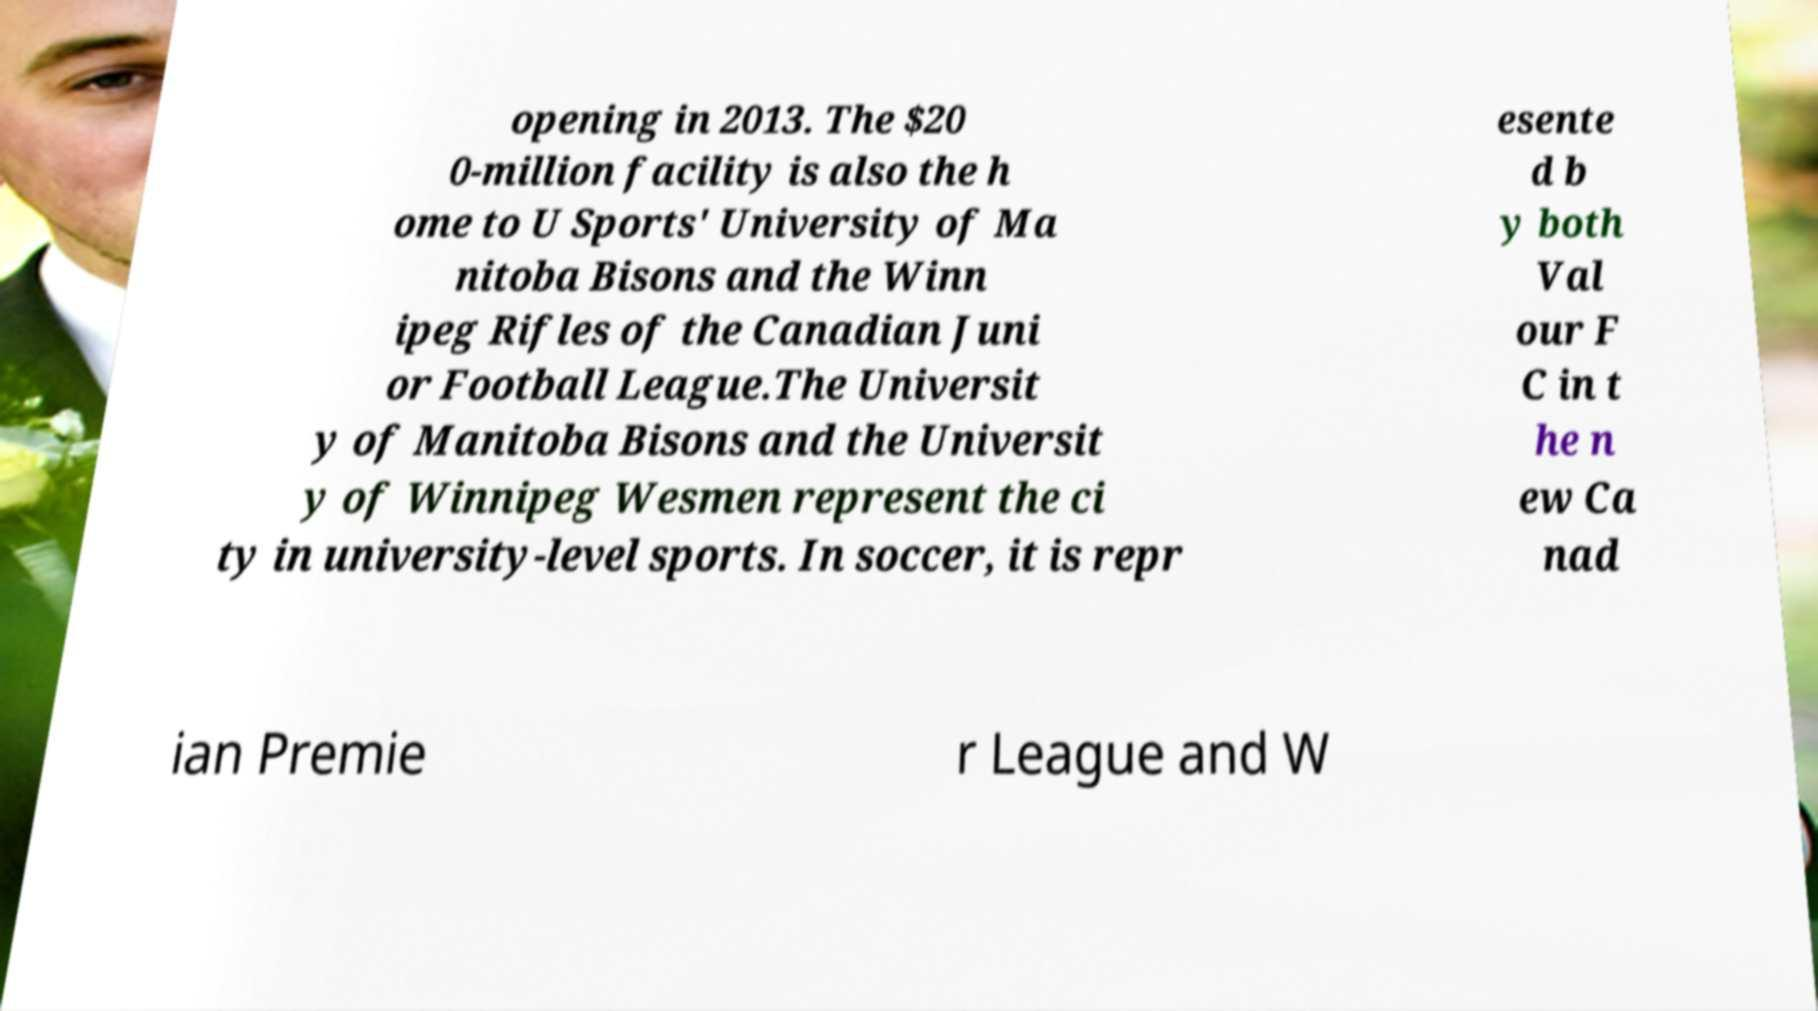Please read and relay the text visible in this image. What does it say? opening in 2013. The $20 0-million facility is also the h ome to U Sports' University of Ma nitoba Bisons and the Winn ipeg Rifles of the Canadian Juni or Football League.The Universit y of Manitoba Bisons and the Universit y of Winnipeg Wesmen represent the ci ty in university-level sports. In soccer, it is repr esente d b y both Val our F C in t he n ew Ca nad ian Premie r League and W 